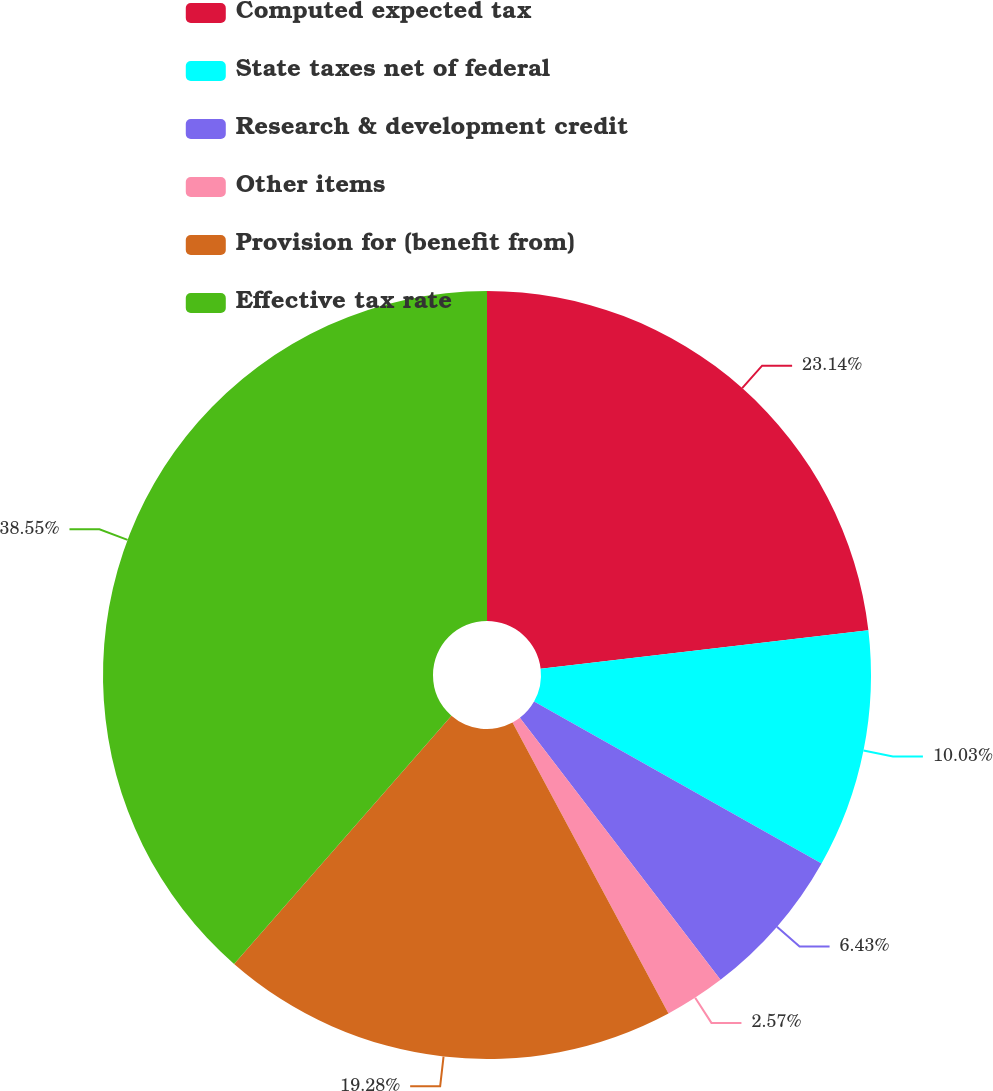Convert chart. <chart><loc_0><loc_0><loc_500><loc_500><pie_chart><fcel>Computed expected tax<fcel>State taxes net of federal<fcel>Research & development credit<fcel>Other items<fcel>Provision for (benefit from)<fcel>Effective tax rate<nl><fcel>23.14%<fcel>10.03%<fcel>6.43%<fcel>2.57%<fcel>19.28%<fcel>38.56%<nl></chart> 